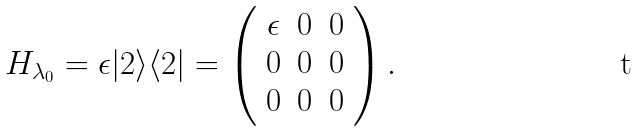Convert formula to latex. <formula><loc_0><loc_0><loc_500><loc_500>H _ { \lambda _ { 0 } } = \epsilon | 2 \rangle \langle 2 | = \left ( \begin{array} { c c c } \epsilon & 0 & 0 \\ 0 & 0 & 0 \\ 0 & 0 & 0 \end{array} \right ) .</formula> 